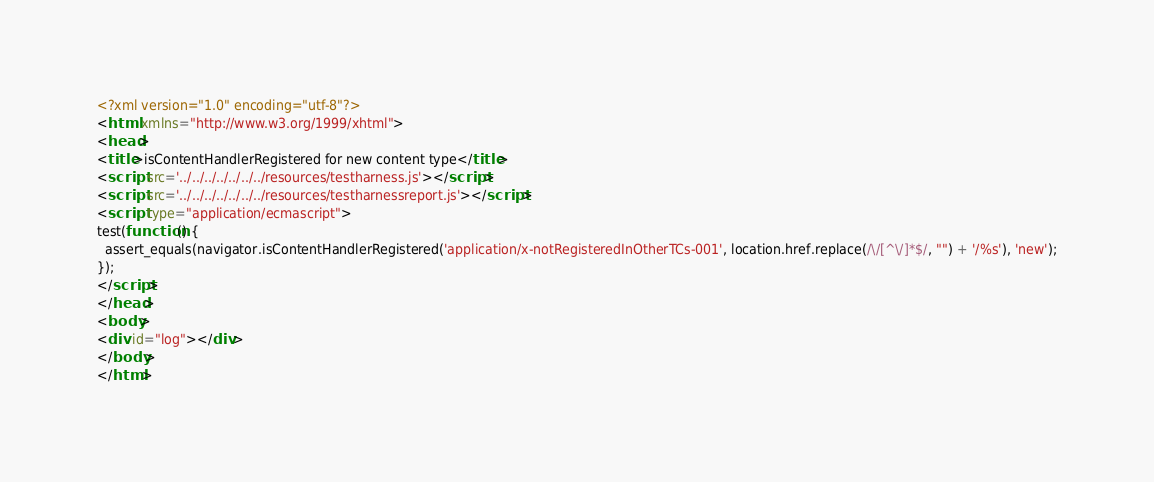Convert code to text. <code><loc_0><loc_0><loc_500><loc_500><_HTML_><?xml version="1.0" encoding="utf-8"?>
<html xmlns="http://www.w3.org/1999/xhtml">
<head>
<title>isContentHandlerRegistered for new content type</title>
<script src='../../../../../../../resources/testharness.js'></script>
<script src='../../../../../../../resources/testharnessreport.js'></script>
<script type="application/ecmascript">
test(function() {
  assert_equals(navigator.isContentHandlerRegistered('application/x-notRegisteredInOtherTCs-001', location.href.replace(/\/[^\/]*$/, "") + '/%s'), 'new');
});
</script>
</head>
<body>
<div id="log"></div>
</body>
</html>
</code> 